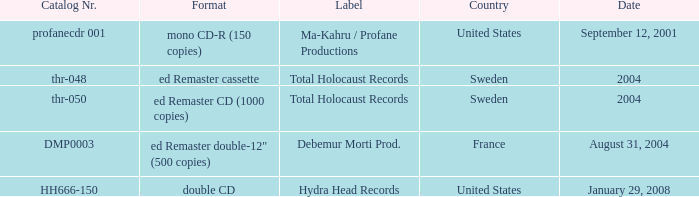In which nation is the remaster double-12" format available with a limited run of 500 copies? France. 